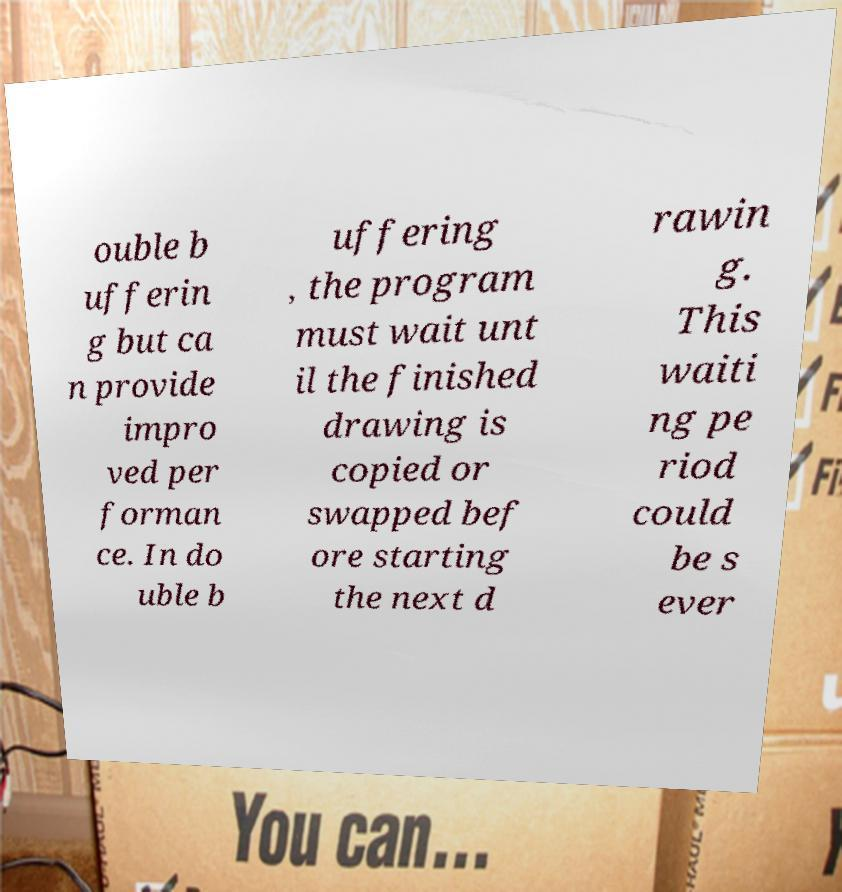There's text embedded in this image that I need extracted. Can you transcribe it verbatim? ouble b ufferin g but ca n provide impro ved per forman ce. In do uble b uffering , the program must wait unt il the finished drawing is copied or swapped bef ore starting the next d rawin g. This waiti ng pe riod could be s ever 